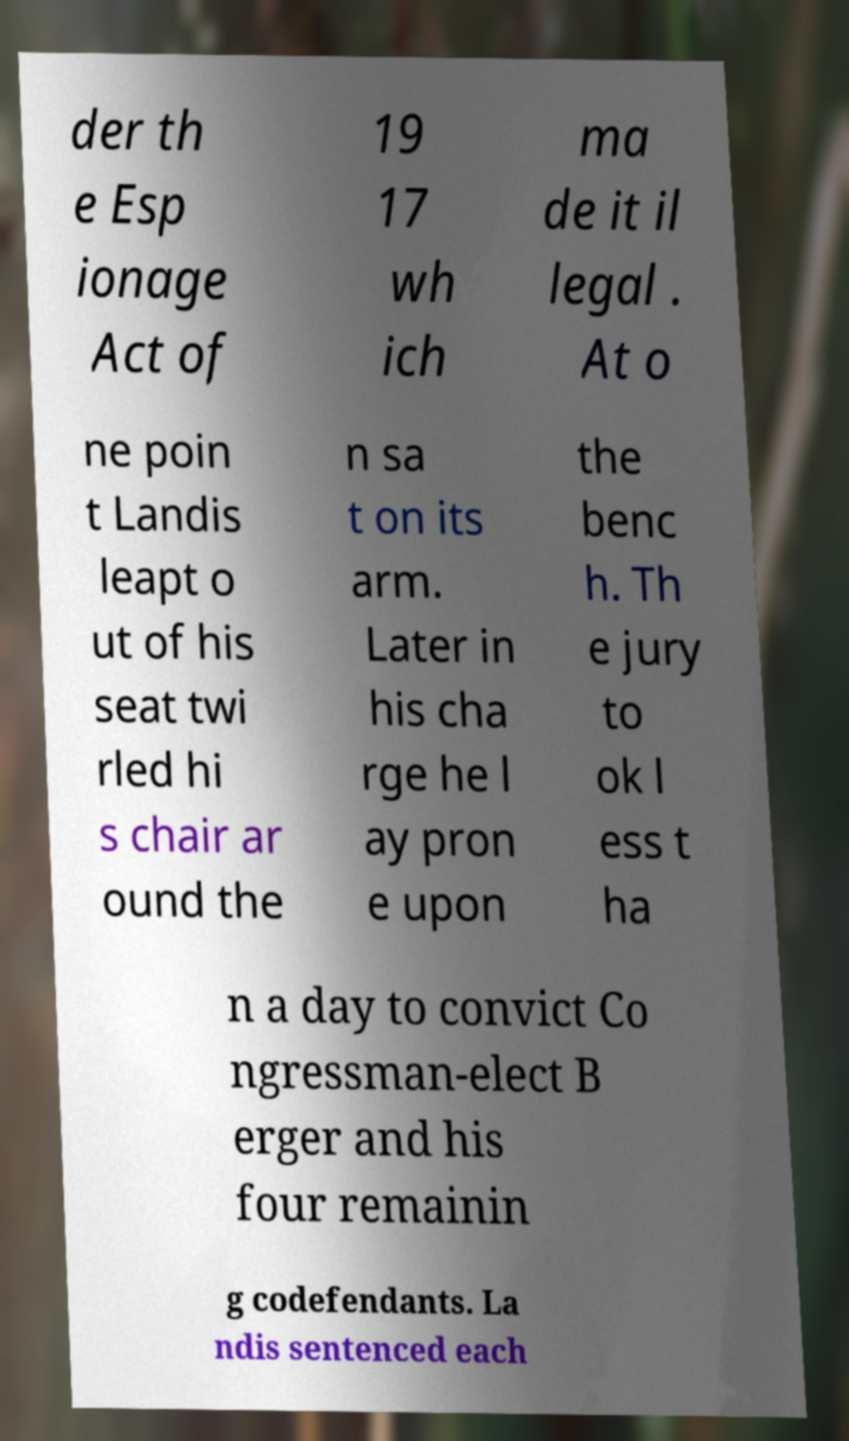Please read and relay the text visible in this image. What does it say? der th e Esp ionage Act of 19 17 wh ich ma de it il legal . At o ne poin t Landis leapt o ut of his seat twi rled hi s chair ar ound the n sa t on its arm. Later in his cha rge he l ay pron e upon the benc h. Th e jury to ok l ess t ha n a day to convict Co ngressman-elect B erger and his four remainin g codefendants. La ndis sentenced each 